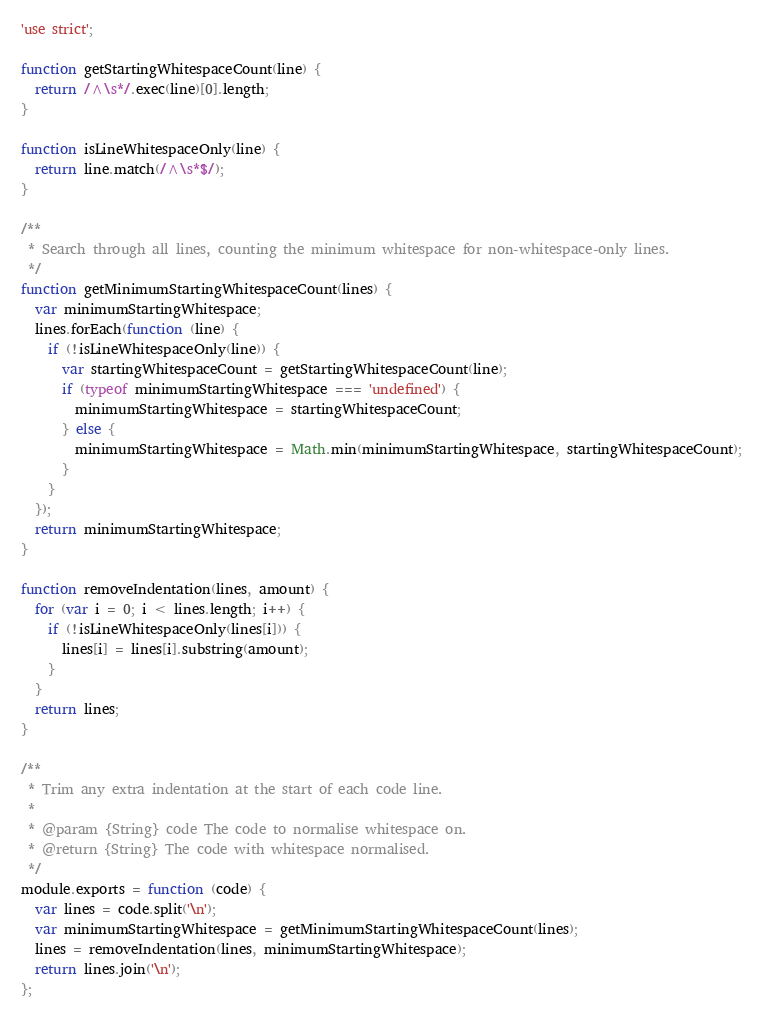<code> <loc_0><loc_0><loc_500><loc_500><_JavaScript_>'use strict';

function getStartingWhitespaceCount(line) {
  return /^\s*/.exec(line)[0].length;
}

function isLineWhitespaceOnly(line) {
  return line.match(/^\s*$/);
}

/**
 * Search through all lines, counting the minimum whitespace for non-whitespace-only lines.
 */
function getMinimumStartingWhitespaceCount(lines) {
  var minimumStartingWhitespace;
  lines.forEach(function (line) {
    if (!isLineWhitespaceOnly(line)) {
      var startingWhitespaceCount = getStartingWhitespaceCount(line);
      if (typeof minimumStartingWhitespace === 'undefined') {
        minimumStartingWhitespace = startingWhitespaceCount;
      } else {
        minimumStartingWhitespace = Math.min(minimumStartingWhitespace, startingWhitespaceCount);
      }
    }
  });
  return minimumStartingWhitespace;
}

function removeIndentation(lines, amount) {
  for (var i = 0; i < lines.length; i++) {
    if (!isLineWhitespaceOnly(lines[i])) {
      lines[i] = lines[i].substring(amount);
    }
  }
  return lines;
}

/**
 * Trim any extra indentation at the start of each code line.
 *
 * @param {String} code The code to normalise whitespace on.
 * @return {String} The code with whitespace normalised.
 */
module.exports = function (code) {
  var lines = code.split('\n');
  var minimumStartingWhitespace = getMinimumStartingWhitespaceCount(lines);
  lines = removeIndentation(lines, minimumStartingWhitespace);
  return lines.join('\n');
};
</code> 